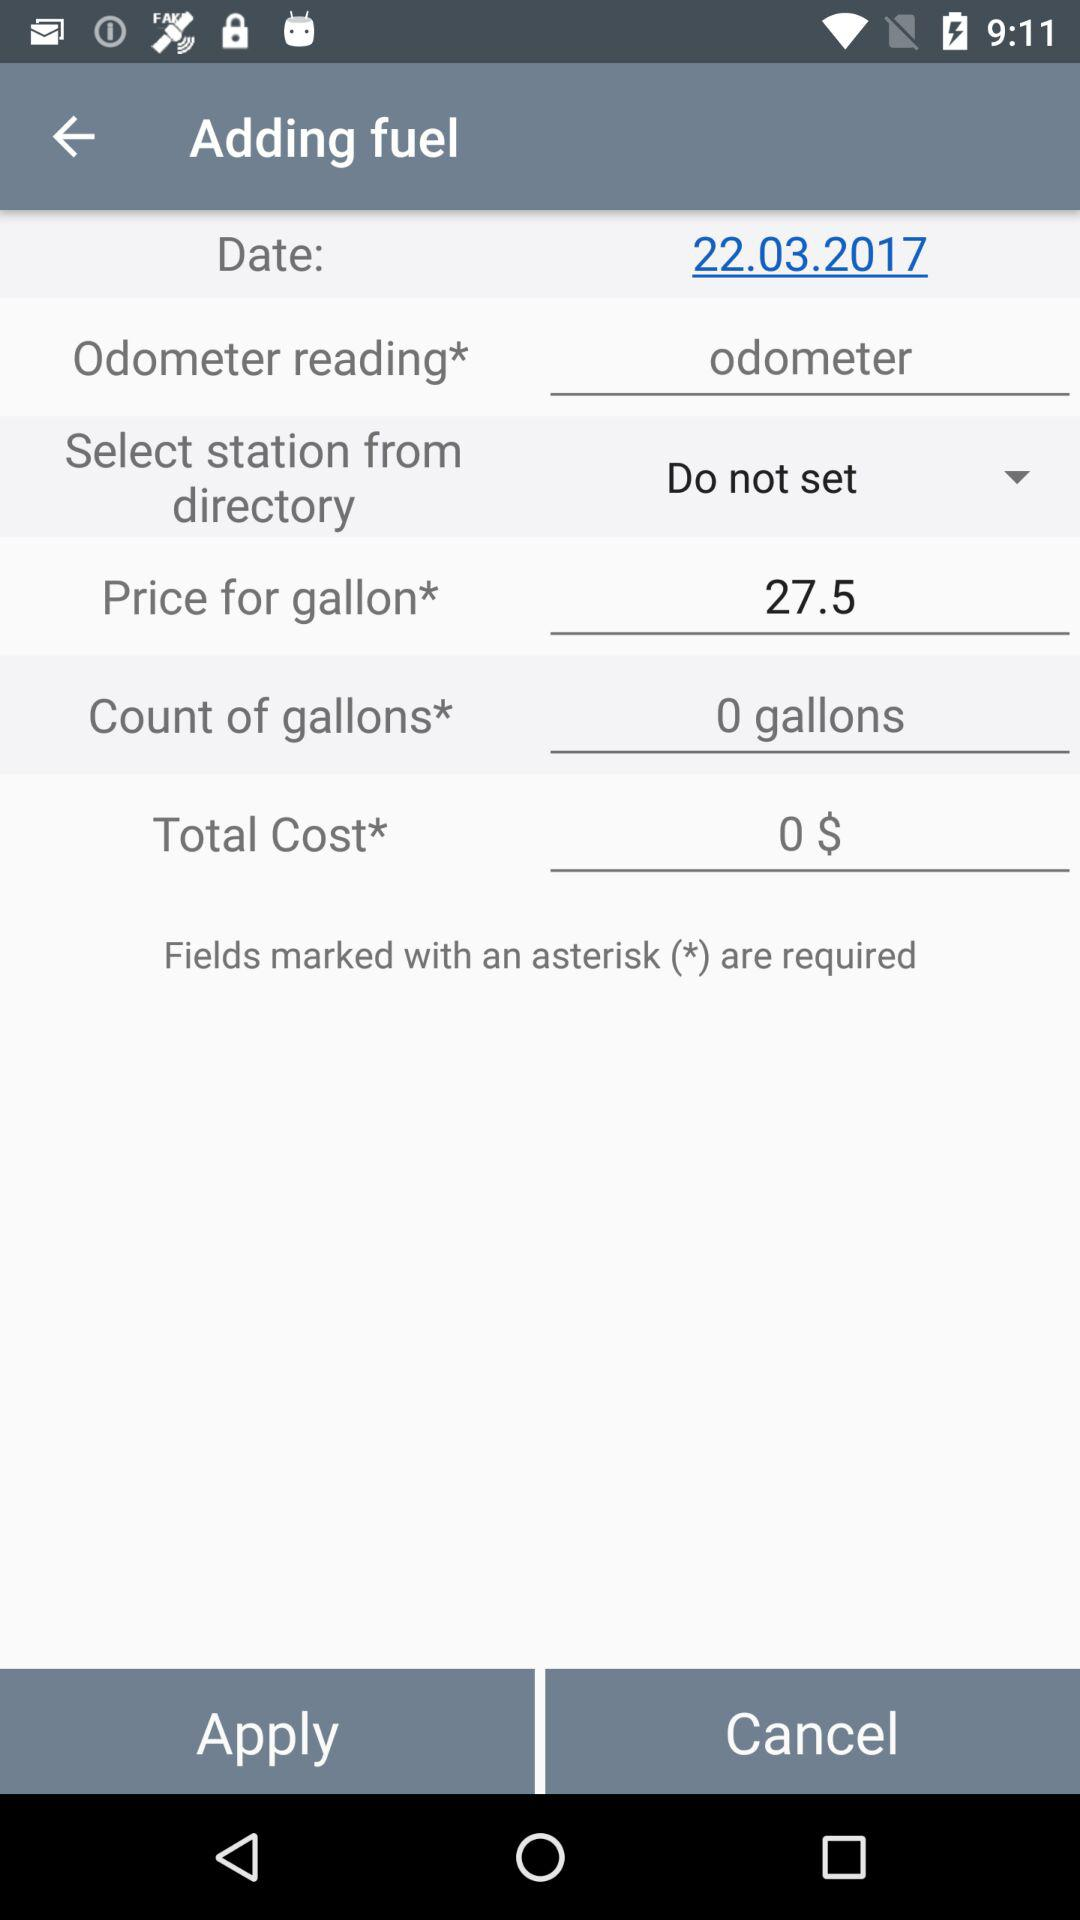What is the count of gallons? The count of gallons is 0. 